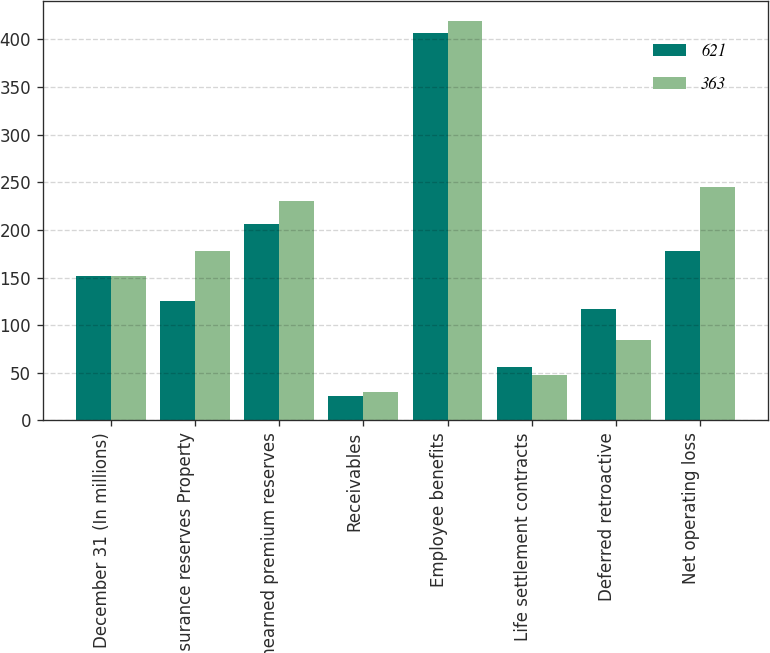<chart> <loc_0><loc_0><loc_500><loc_500><stacked_bar_chart><ecel><fcel>December 31 (In millions)<fcel>Insurance reserves Property<fcel>Unearned premium reserves<fcel>Receivables<fcel>Employee benefits<fcel>Life settlement contracts<fcel>Deferred retroactive<fcel>Net operating loss<nl><fcel>621<fcel>151.5<fcel>125<fcel>206<fcel>26<fcel>407<fcel>56<fcel>117<fcel>178<nl><fcel>363<fcel>151.5<fcel>178<fcel>230<fcel>30<fcel>419<fcel>48<fcel>84<fcel>245<nl></chart> 